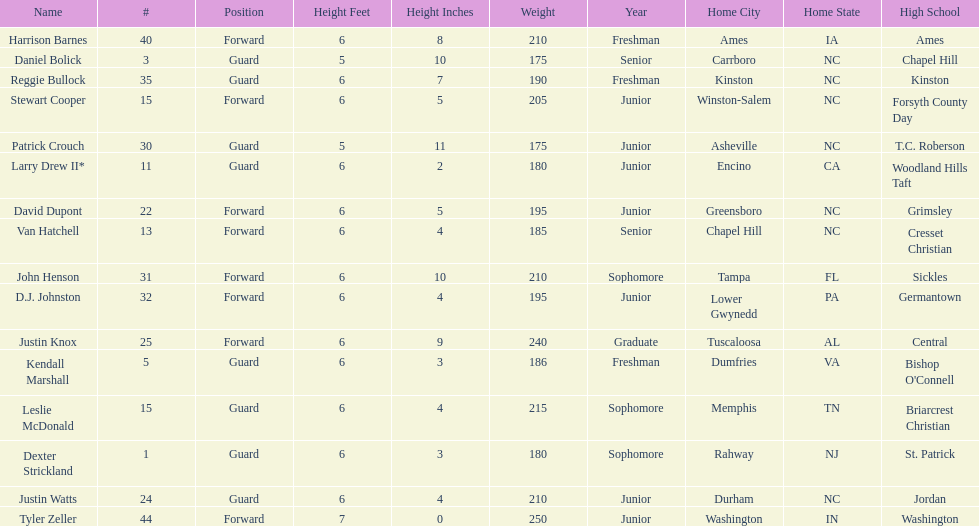How many players play a position other than guard? 8. 